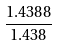Convert formula to latex. <formula><loc_0><loc_0><loc_500><loc_500>\frac { 1 . 4 3 8 8 } { 1 . 4 3 8 }</formula> 